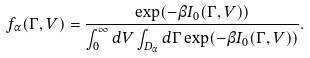<formula> <loc_0><loc_0><loc_500><loc_500>f _ { \alpha } ( \Gamma , V ) = \frac { \exp ( - \beta I _ { 0 } ( \Gamma , V ) ) } { \int _ { 0 } ^ { \infty } d V \int _ { D _ { \alpha } } d \Gamma \exp ( - \beta I _ { 0 } ( \Gamma , V ) ) } .</formula> 